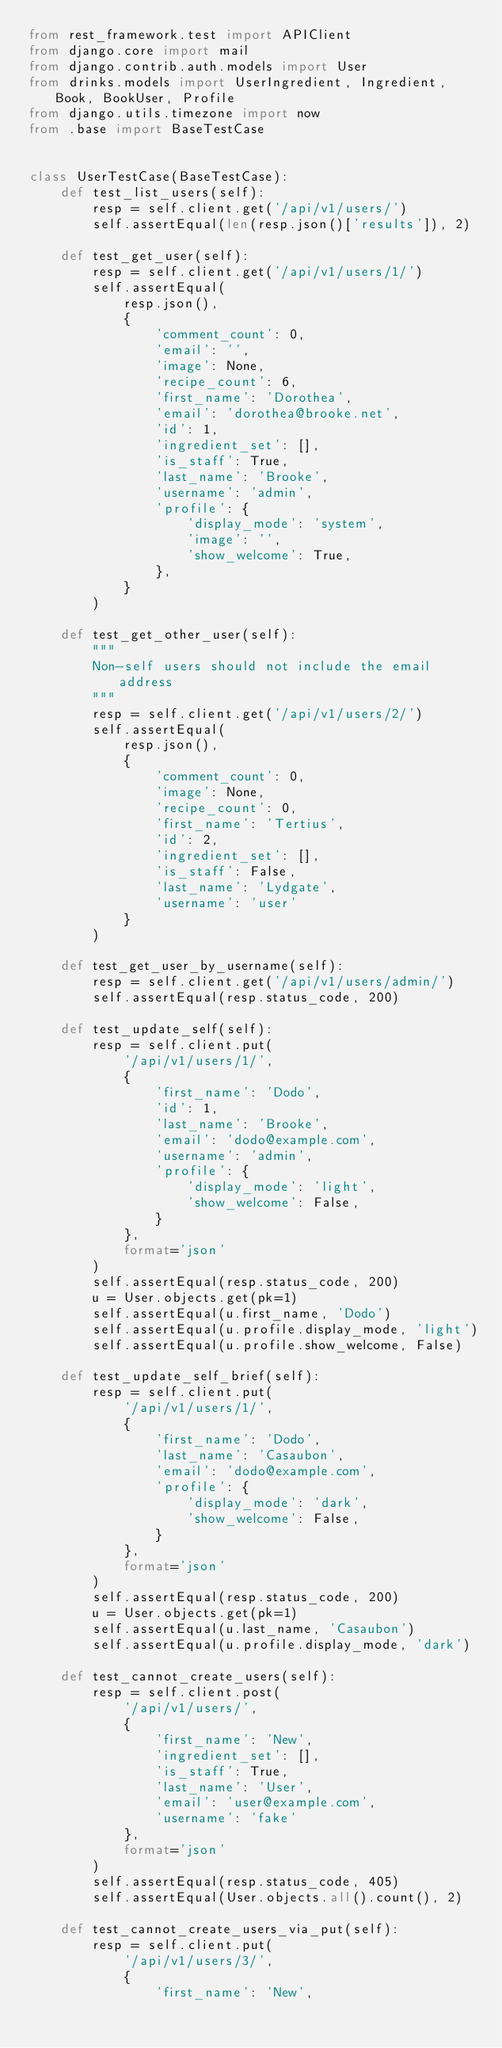Convert code to text. <code><loc_0><loc_0><loc_500><loc_500><_Python_>from rest_framework.test import APIClient
from django.core import mail
from django.contrib.auth.models import User
from drinks.models import UserIngredient, Ingredient, Book, BookUser, Profile
from django.utils.timezone import now
from .base import BaseTestCase


class UserTestCase(BaseTestCase):
    def test_list_users(self):
        resp = self.client.get('/api/v1/users/')
        self.assertEqual(len(resp.json()['results']), 2)

    def test_get_user(self):
        resp = self.client.get('/api/v1/users/1/')
        self.assertEqual(
            resp.json(),
            {
                'comment_count': 0,
                'email': '',
                'image': None,
                'recipe_count': 6,
                'first_name': 'Dorothea',
                'email': 'dorothea@brooke.net',
                'id': 1,
                'ingredient_set': [],
                'is_staff': True,
                'last_name': 'Brooke',
                'username': 'admin',
                'profile': {
                    'display_mode': 'system',
                    'image': '',
                    'show_welcome': True,
                },
            }
        )

    def test_get_other_user(self):
        """
        Non-self users should not include the email address
        """
        resp = self.client.get('/api/v1/users/2/')
        self.assertEqual(
            resp.json(),
            {
                'comment_count': 0,
                'image': None,
                'recipe_count': 0,
                'first_name': 'Tertius',
                'id': 2,
                'ingredient_set': [],
                'is_staff': False,
                'last_name': 'Lydgate',
                'username': 'user'
            }
        )

    def test_get_user_by_username(self):
        resp = self.client.get('/api/v1/users/admin/')
        self.assertEqual(resp.status_code, 200)

    def test_update_self(self):
        resp = self.client.put(
            '/api/v1/users/1/',
            {
                'first_name': 'Dodo',
                'id': 1,
                'last_name': 'Brooke',
                'email': 'dodo@example.com',
                'username': 'admin',
                'profile': {
                    'display_mode': 'light',
                    'show_welcome': False,
                }
            },
            format='json'
        )
        self.assertEqual(resp.status_code, 200)
        u = User.objects.get(pk=1)
        self.assertEqual(u.first_name, 'Dodo')
        self.assertEqual(u.profile.display_mode, 'light')
        self.assertEqual(u.profile.show_welcome, False)

    def test_update_self_brief(self):
        resp = self.client.put(
            '/api/v1/users/1/',
            {
                'first_name': 'Dodo',
                'last_name': 'Casaubon',
                'email': 'dodo@example.com',
                'profile': {
                    'display_mode': 'dark',
                    'show_welcome': False,
                }
            },
            format='json'
        )
        self.assertEqual(resp.status_code, 200)
        u = User.objects.get(pk=1)
        self.assertEqual(u.last_name, 'Casaubon')
        self.assertEqual(u.profile.display_mode, 'dark')

    def test_cannot_create_users(self):
        resp = self.client.post(
            '/api/v1/users/',
            {
                'first_name': 'New',
                'ingredient_set': [],
                'is_staff': True,
                'last_name': 'User',
                'email': 'user@example.com',
                'username': 'fake'
            },
            format='json'
        )
        self.assertEqual(resp.status_code, 405)
        self.assertEqual(User.objects.all().count(), 2)

    def test_cannot_create_users_via_put(self):
        resp = self.client.put(
            '/api/v1/users/3/',
            {
                'first_name': 'New',</code> 